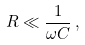Convert formula to latex. <formula><loc_0><loc_0><loc_500><loc_500>R \ll { \frac { 1 } { \omega C } } \, ,</formula> 